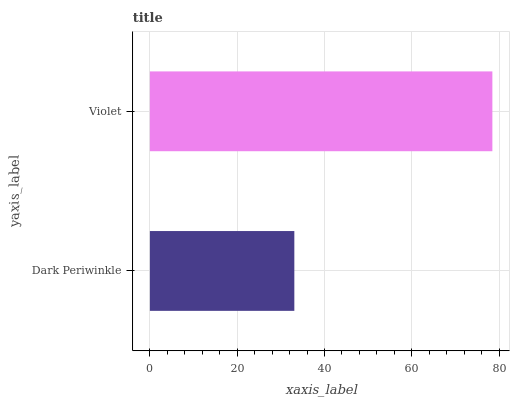Is Dark Periwinkle the minimum?
Answer yes or no. Yes. Is Violet the maximum?
Answer yes or no. Yes. Is Violet the minimum?
Answer yes or no. No. Is Violet greater than Dark Periwinkle?
Answer yes or no. Yes. Is Dark Periwinkle less than Violet?
Answer yes or no. Yes. Is Dark Periwinkle greater than Violet?
Answer yes or no. No. Is Violet less than Dark Periwinkle?
Answer yes or no. No. Is Violet the high median?
Answer yes or no. Yes. Is Dark Periwinkle the low median?
Answer yes or no. Yes. Is Dark Periwinkle the high median?
Answer yes or no. No. Is Violet the low median?
Answer yes or no. No. 